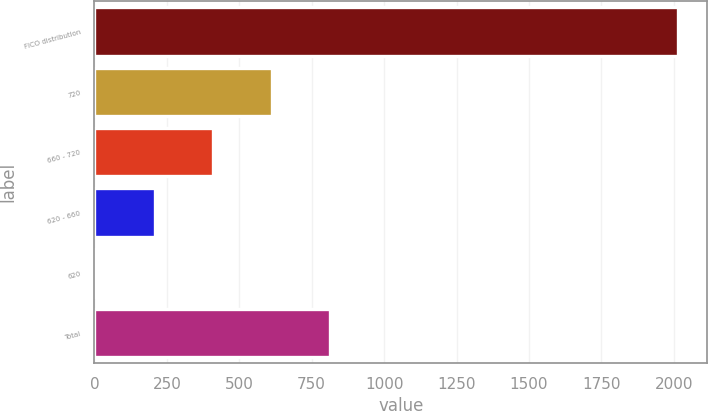Convert chart. <chart><loc_0><loc_0><loc_500><loc_500><bar_chart><fcel>FICO distribution<fcel>720<fcel>660 - 720<fcel>620 - 660<fcel>620<fcel>Total<nl><fcel>2015<fcel>611.5<fcel>411<fcel>210.5<fcel>10<fcel>812<nl></chart> 